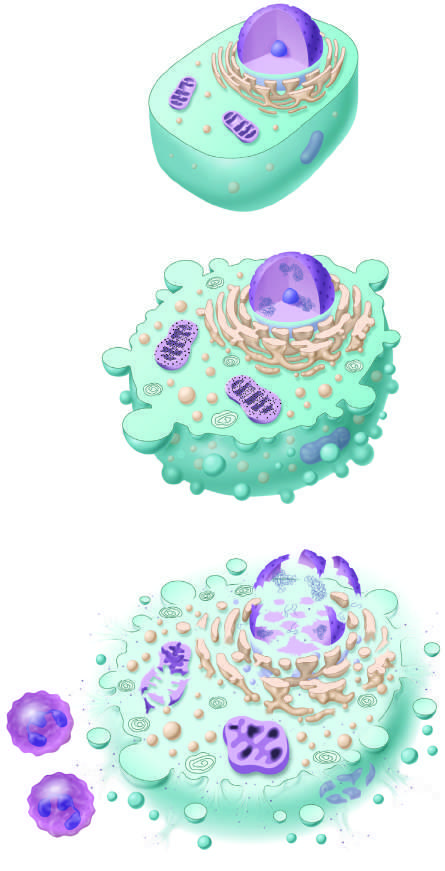s reversible injury considered to culminate in necrosis if the injurious stimulus is not removed by convention?
Answer the question using a single word or phrase. Yes 